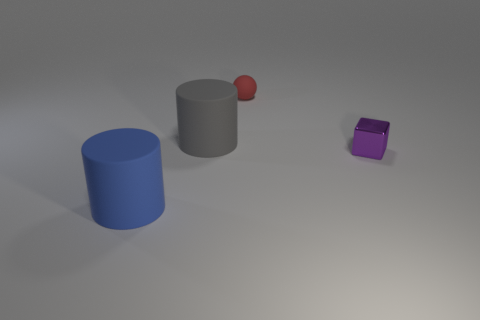Add 1 purple metallic blocks. How many objects exist? 5 Subtract all balls. How many objects are left? 3 Add 1 red metallic cylinders. How many red metallic cylinders exist? 1 Subtract 0 green blocks. How many objects are left? 4 Subtract all matte objects. Subtract all small red objects. How many objects are left? 0 Add 2 small purple things. How many small purple things are left? 3 